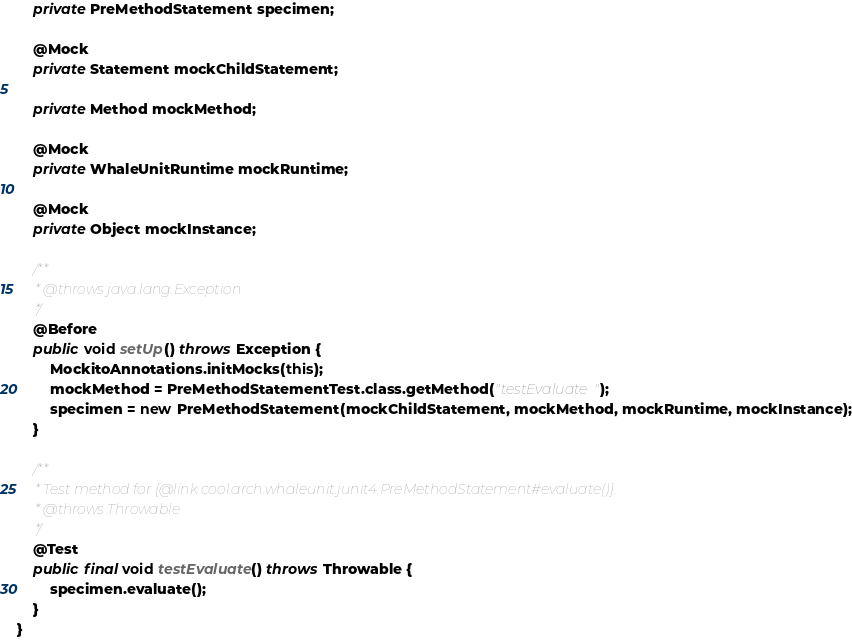Convert code to text. <code><loc_0><loc_0><loc_500><loc_500><_Java_>	private PreMethodStatement specimen;

	@Mock
	private Statement mockChildStatement;

	private Method mockMethod;

	@Mock
	private WhaleUnitRuntime mockRuntime;

	@Mock
	private Object mockInstance;

	/**
	 * @throws java.lang.Exception
	 */
	@Before
	public void setUp() throws Exception {
		MockitoAnnotations.initMocks(this);
		mockMethod = PreMethodStatementTest.class.getMethod("testEvaluate");
		specimen = new PreMethodStatement(mockChildStatement, mockMethod, mockRuntime, mockInstance);
	}

	/**
	 * Test method for {@link cool.arch.whaleunit.junit4.PreMethodStatement#evaluate()}.
	 * @throws Throwable 
	 */
	@Test
	public final void testEvaluate() throws Throwable {
		specimen.evaluate();
	}
}
</code> 